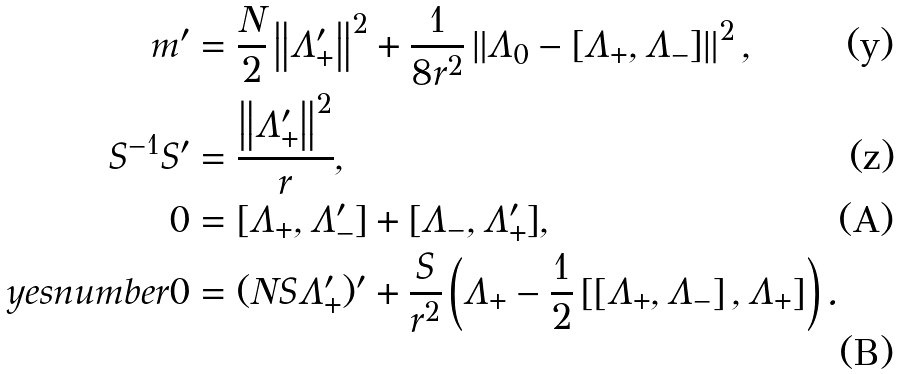Convert formula to latex. <formula><loc_0><loc_0><loc_500><loc_500>m ^ { \prime } & = \frac { N } { 2 } \left \| \Lambda _ { + } ^ { \prime } \right \| ^ { 2 } + \frac { 1 } { 8 r ^ { 2 } } \left \| \Lambda _ { 0 } - [ \Lambda _ { + } , \Lambda _ { - } ] \right \| ^ { 2 } , & \\ S ^ { - 1 } S ^ { \prime } & = \frac { \left \| \Lambda _ { + } ^ { \prime } \right \| ^ { 2 } } { r } , & \\ 0 & = [ \Lambda _ { + } , \Lambda _ { - } ^ { \prime } ] + [ \Lambda _ { - } , \Lambda _ { + } ^ { \prime } ] , & \\ \ y e s n u m b e r 0 & = ( N S \Lambda _ { + } ^ { \prime } ) ^ { \prime } + \frac { S } { r ^ { 2 } } \left ( \Lambda _ { + } - \frac { 1 } { 2 } \left [ \left [ \Lambda _ { + } , \Lambda _ { - } \right ] , \Lambda _ { + } \right ] \right ) . &</formula> 